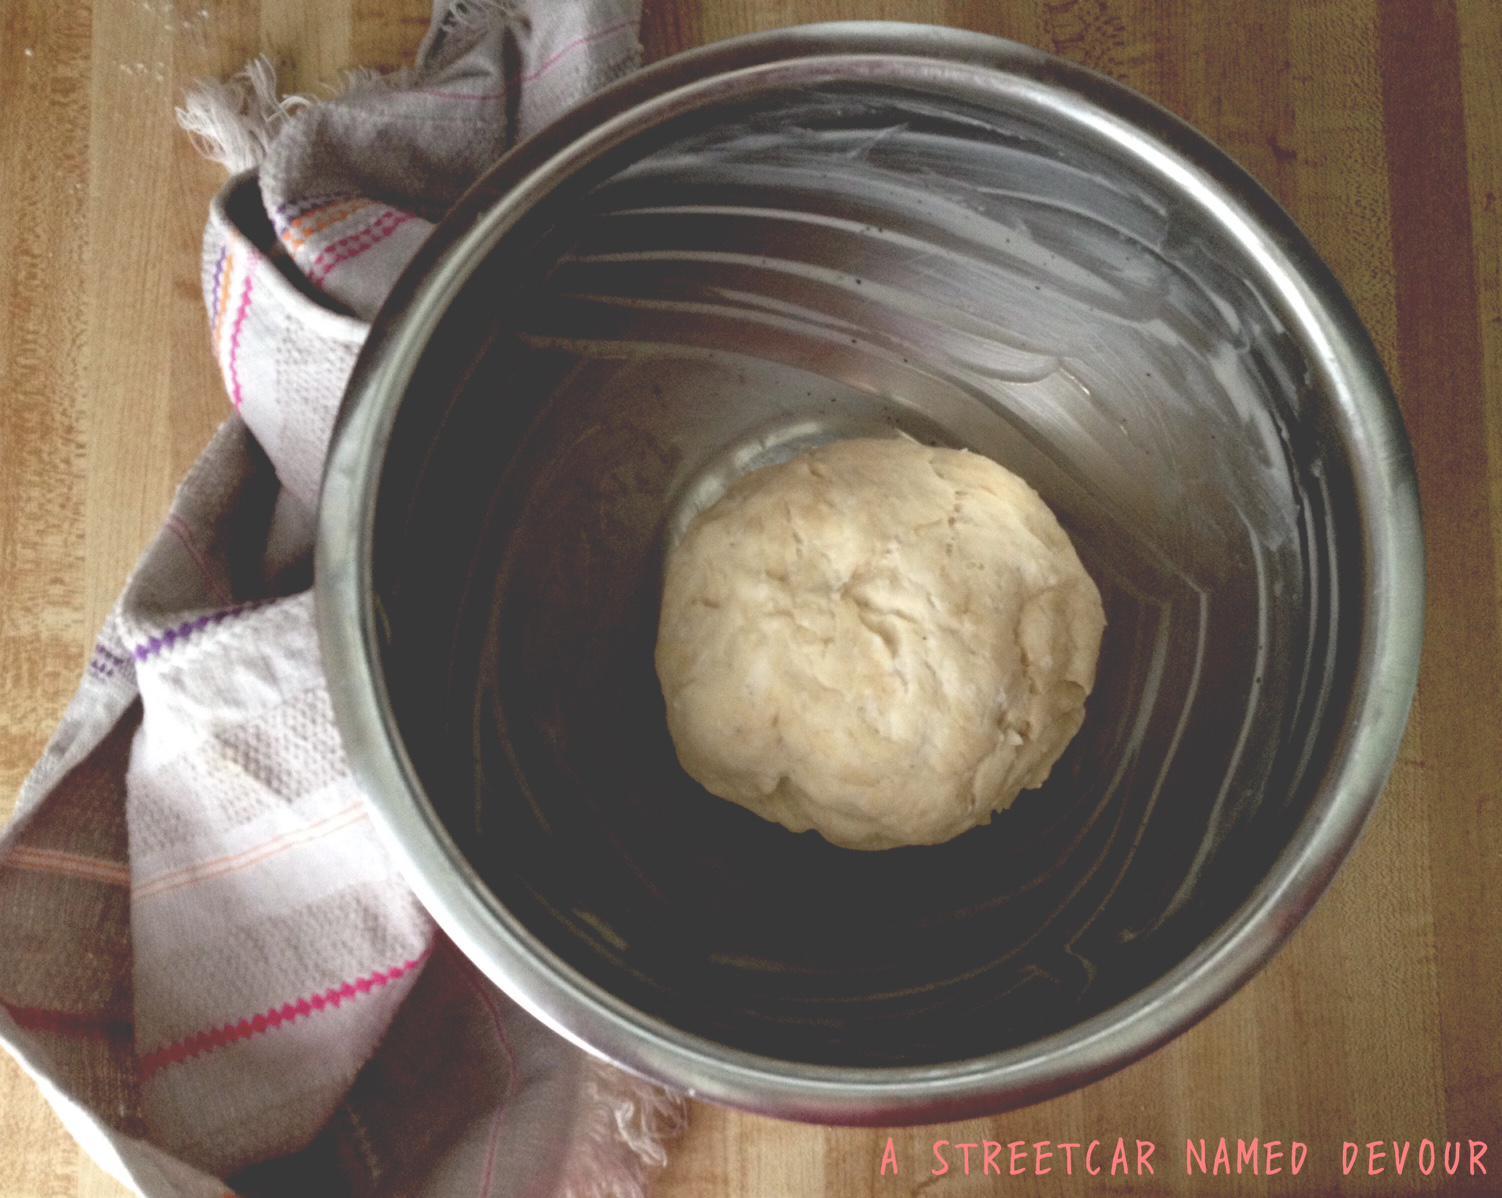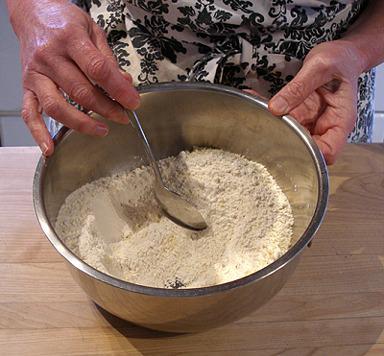The first image is the image on the left, the second image is the image on the right. Analyze the images presented: Is the assertion "In one of the images, the person's hand is pouring an ingredient into the bowl." valid? Answer yes or no. No. The first image is the image on the left, the second image is the image on the right. Assess this claim about the two images: "The right image shows one hand holding a spoon in a silver-colored bowl as the other hand grips the edge of the bowl.". Correct or not? Answer yes or no. Yes. 